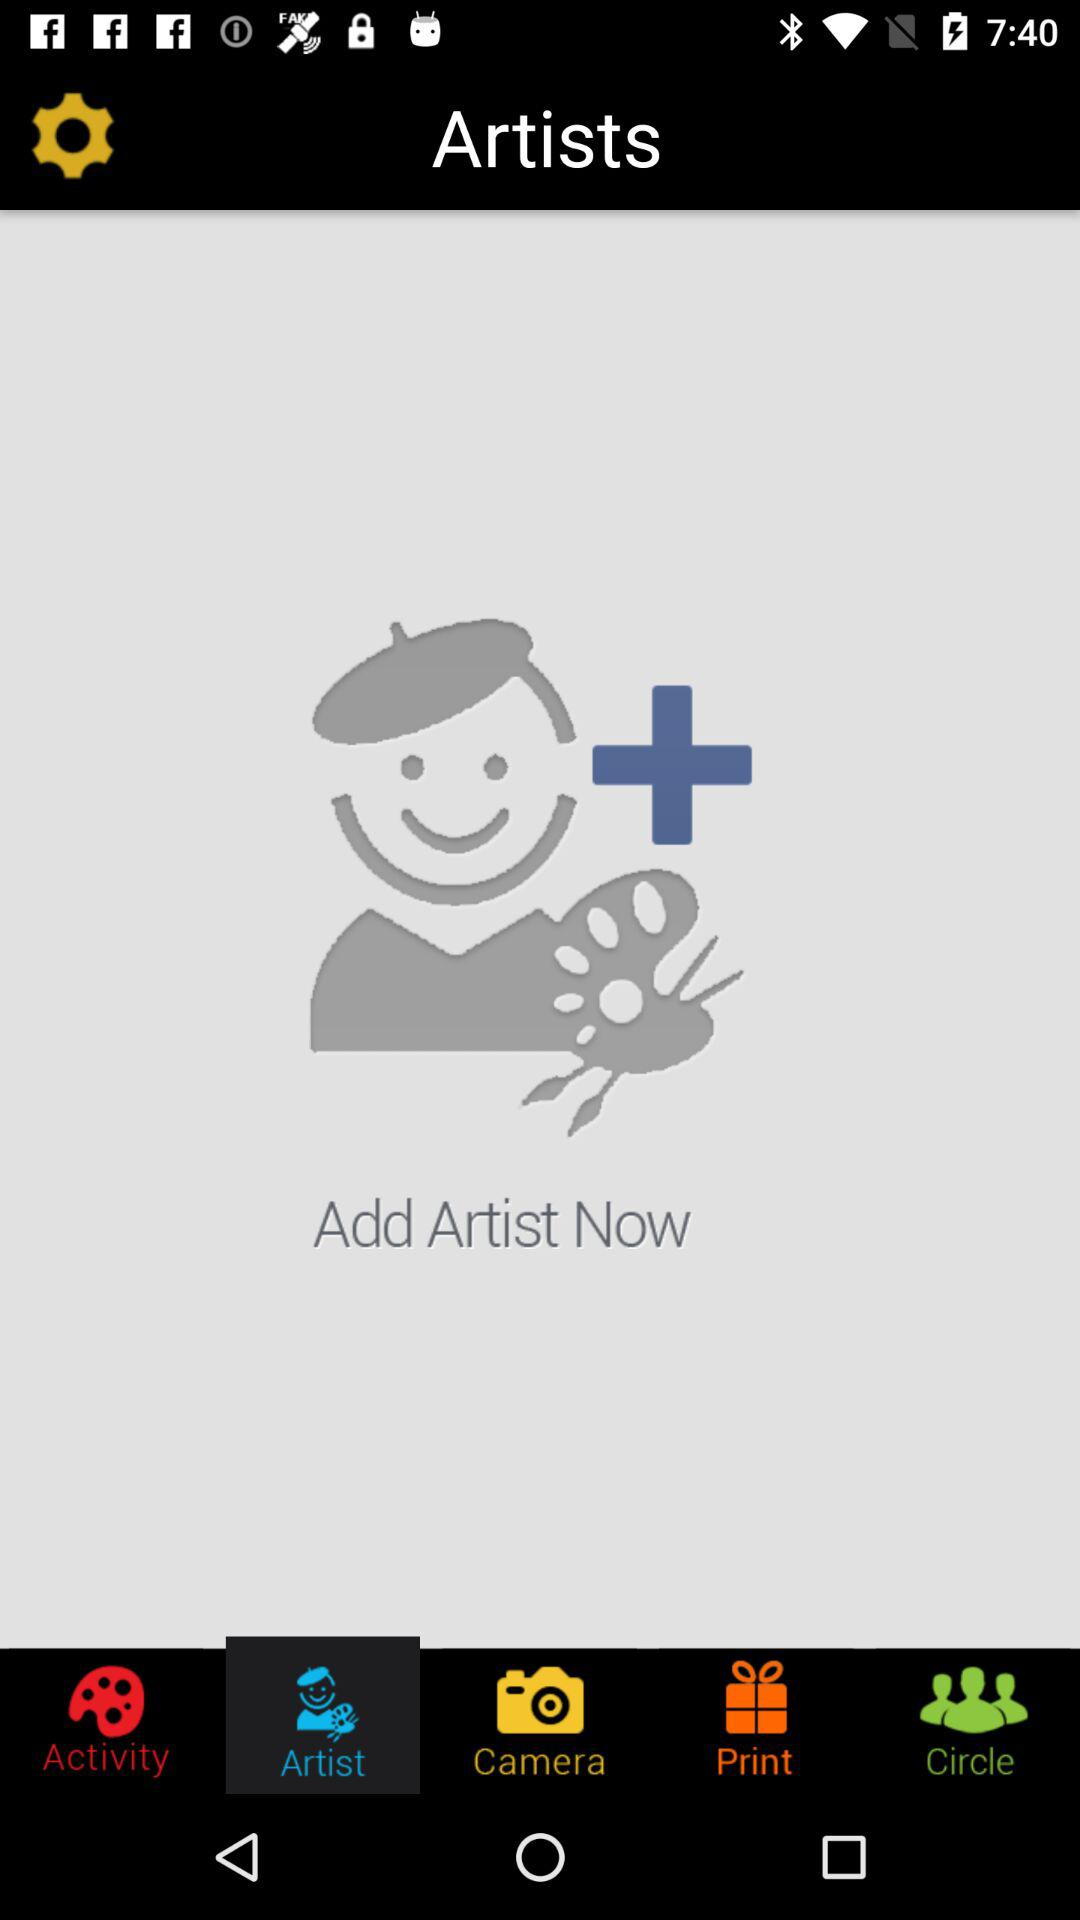Which tab is selected? The selected tab is "Artist". 